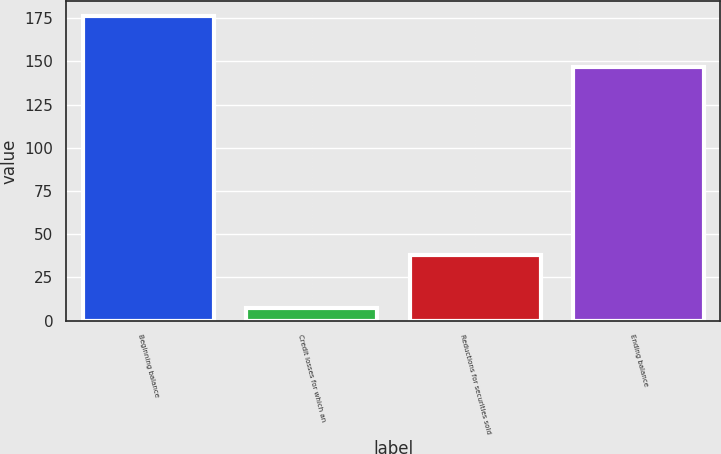<chart> <loc_0><loc_0><loc_500><loc_500><bar_chart><fcel>Beginning balance<fcel>Credit losses for which an<fcel>Reductions for securities sold<fcel>Ending balance<nl><fcel>176<fcel>7<fcel>38<fcel>147<nl></chart> 